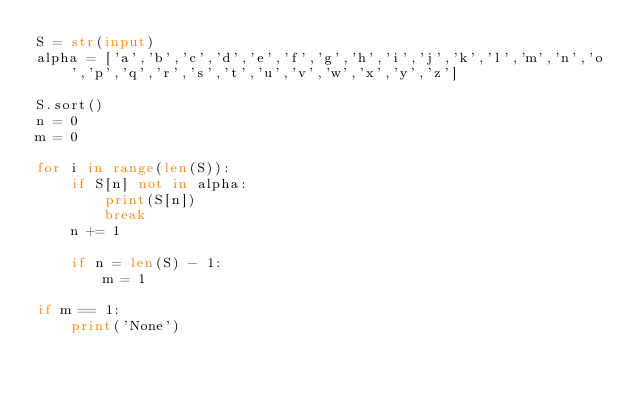<code> <loc_0><loc_0><loc_500><loc_500><_Python_>S = str(input)
alpha = ['a','b','c','d','e','f','g','h','i','j','k','l','m','n','o','p','q','r','s','t','u','v','w','x','y','z']

S.sort()
n = 0
m = 0

for i in range(len(S)):
	if S[n] not in alpha:
		print(S[n])
		break
	n += 1

	if n = len(S) - 1:
		m = 1

if m == 1:
	print('None')</code> 